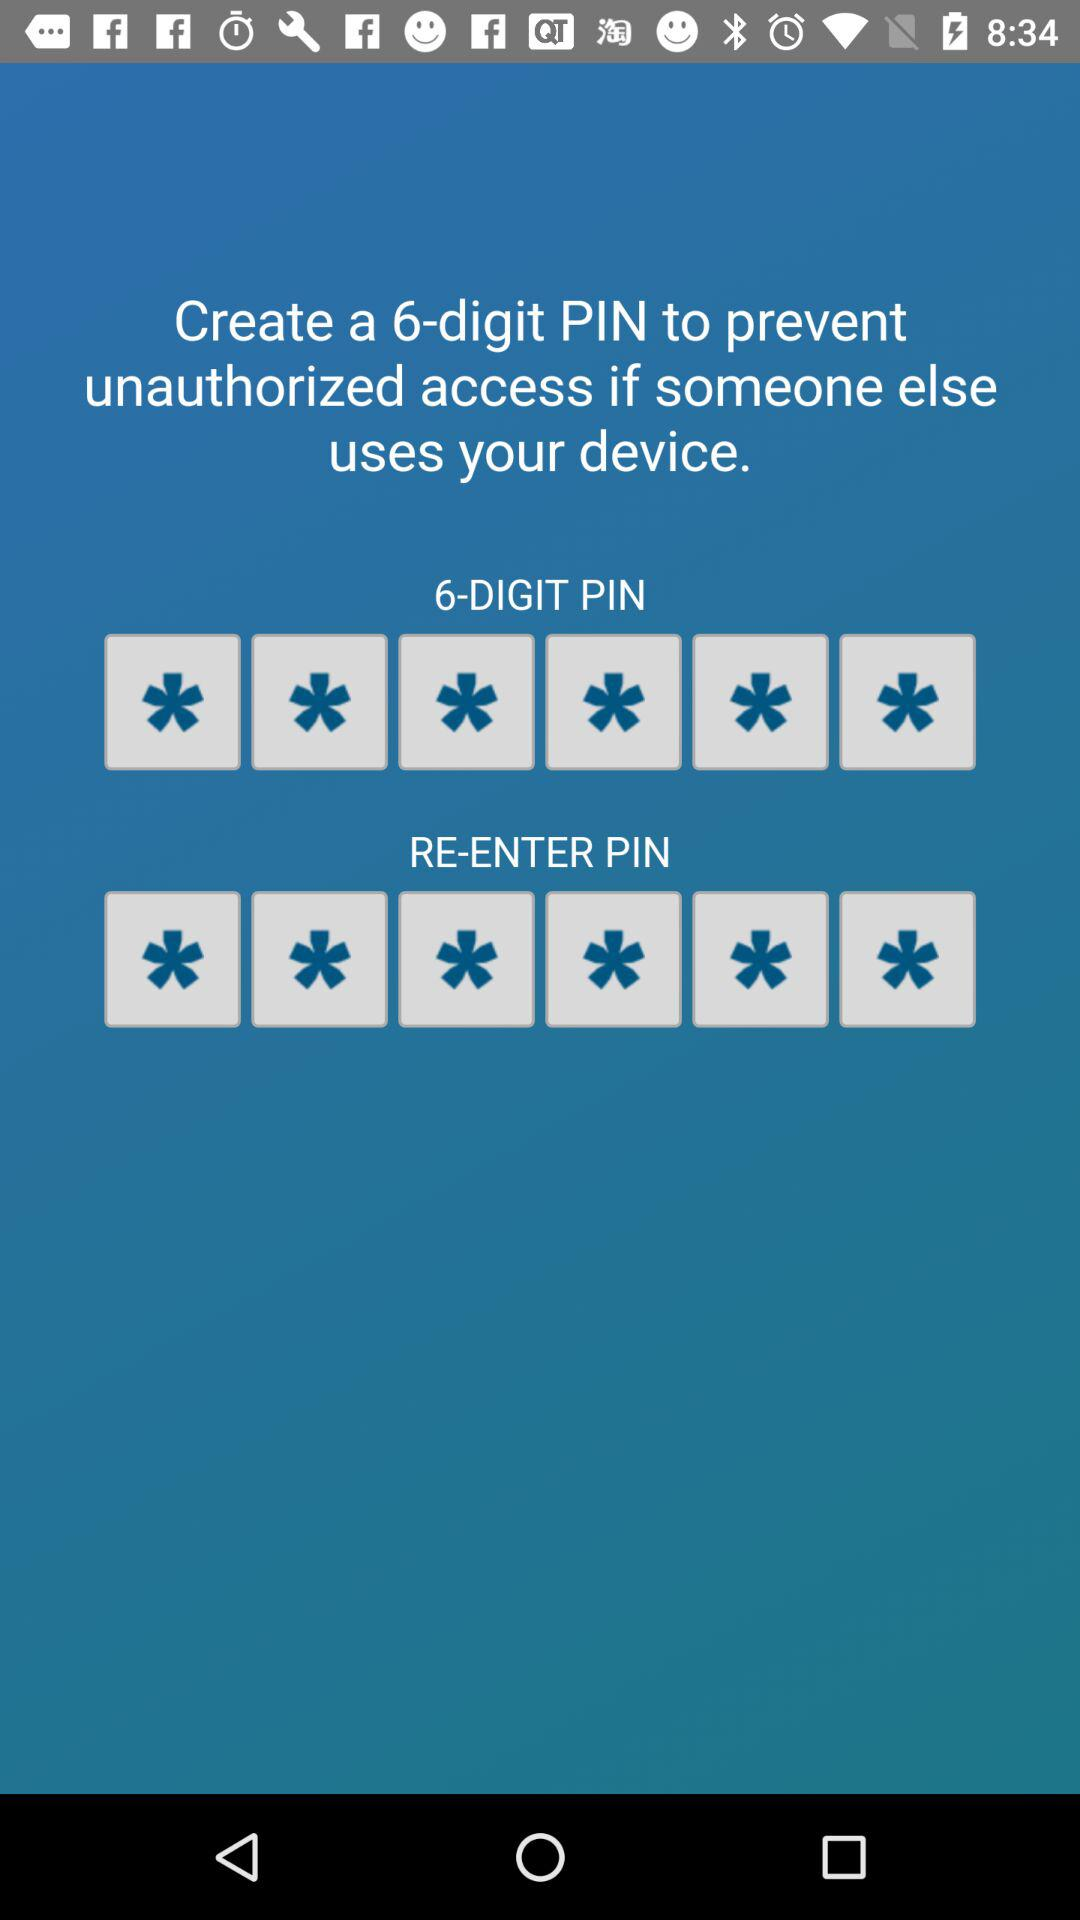How many digits are there in the PIN?
Answer the question using a single word or phrase. 6 